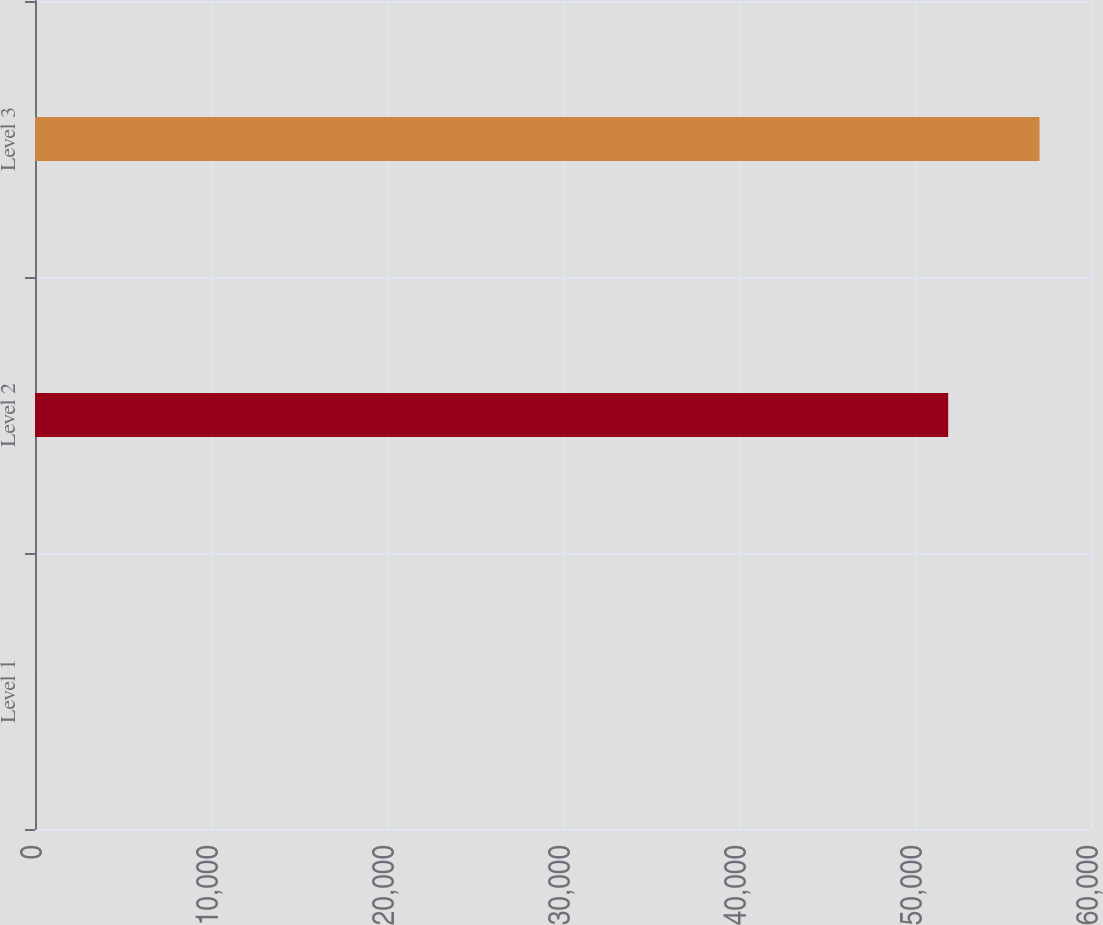Convert chart to OTSL. <chart><loc_0><loc_0><loc_500><loc_500><bar_chart><fcel>Level 1<fcel>Level 2<fcel>Level 3<nl><fcel>2.3<fcel>51886<fcel>57074.4<nl></chart> 